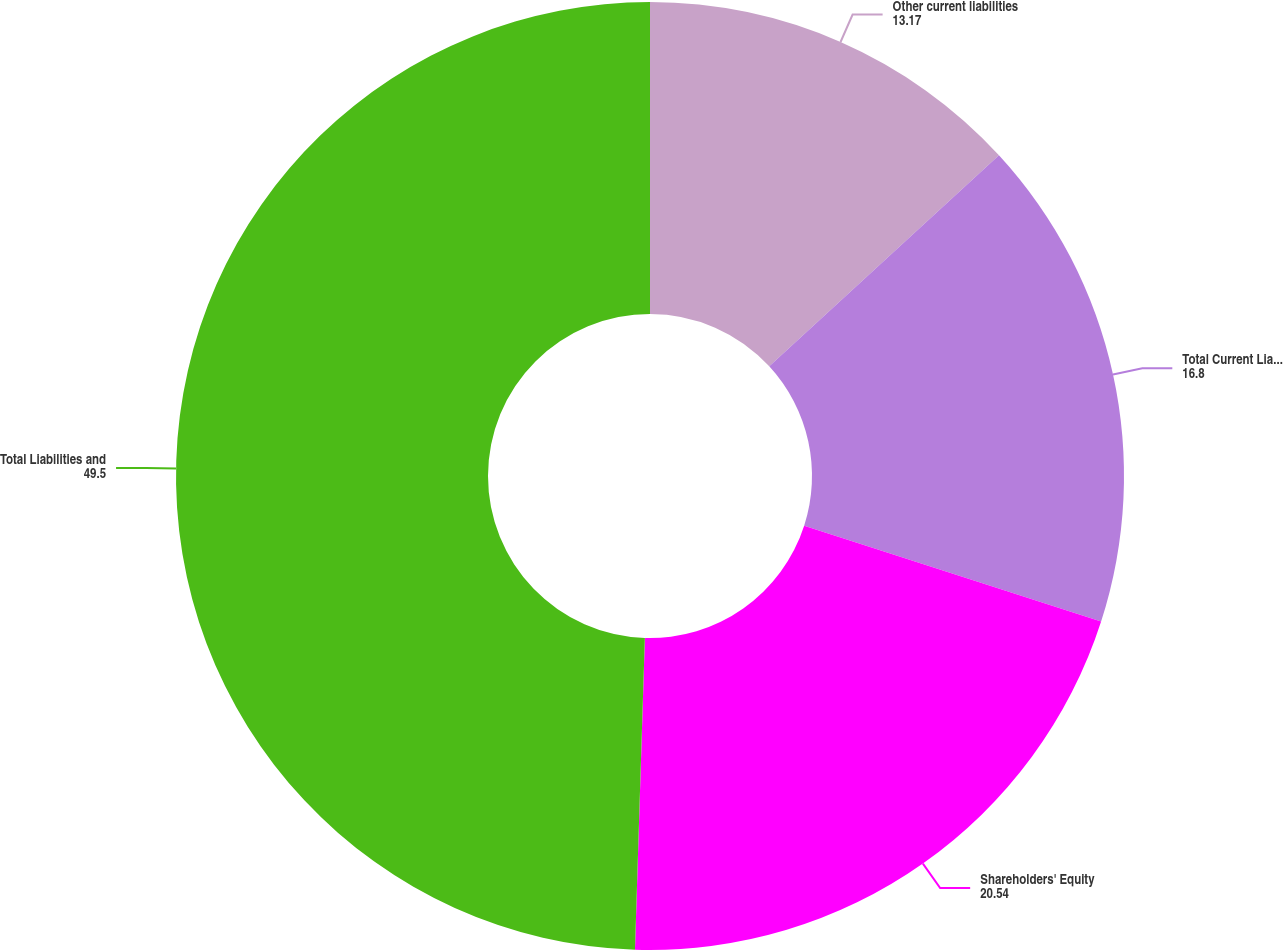<chart> <loc_0><loc_0><loc_500><loc_500><pie_chart><fcel>Other current liabilities<fcel>Total Current Liabilities<fcel>Shareholders' Equity<fcel>Total Liabilities and<nl><fcel>13.17%<fcel>16.8%<fcel>20.54%<fcel>49.5%<nl></chart> 